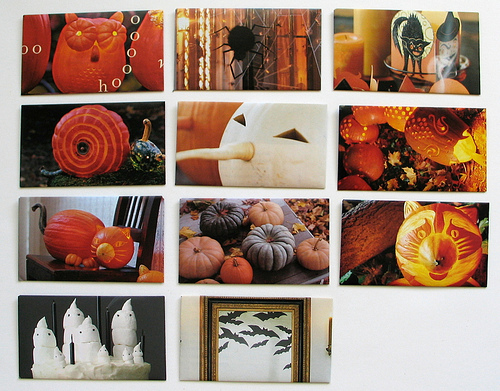<image>
Is there a pumpkin above the bats? No. The pumpkin is not positioned above the bats. The vertical arrangement shows a different relationship. 